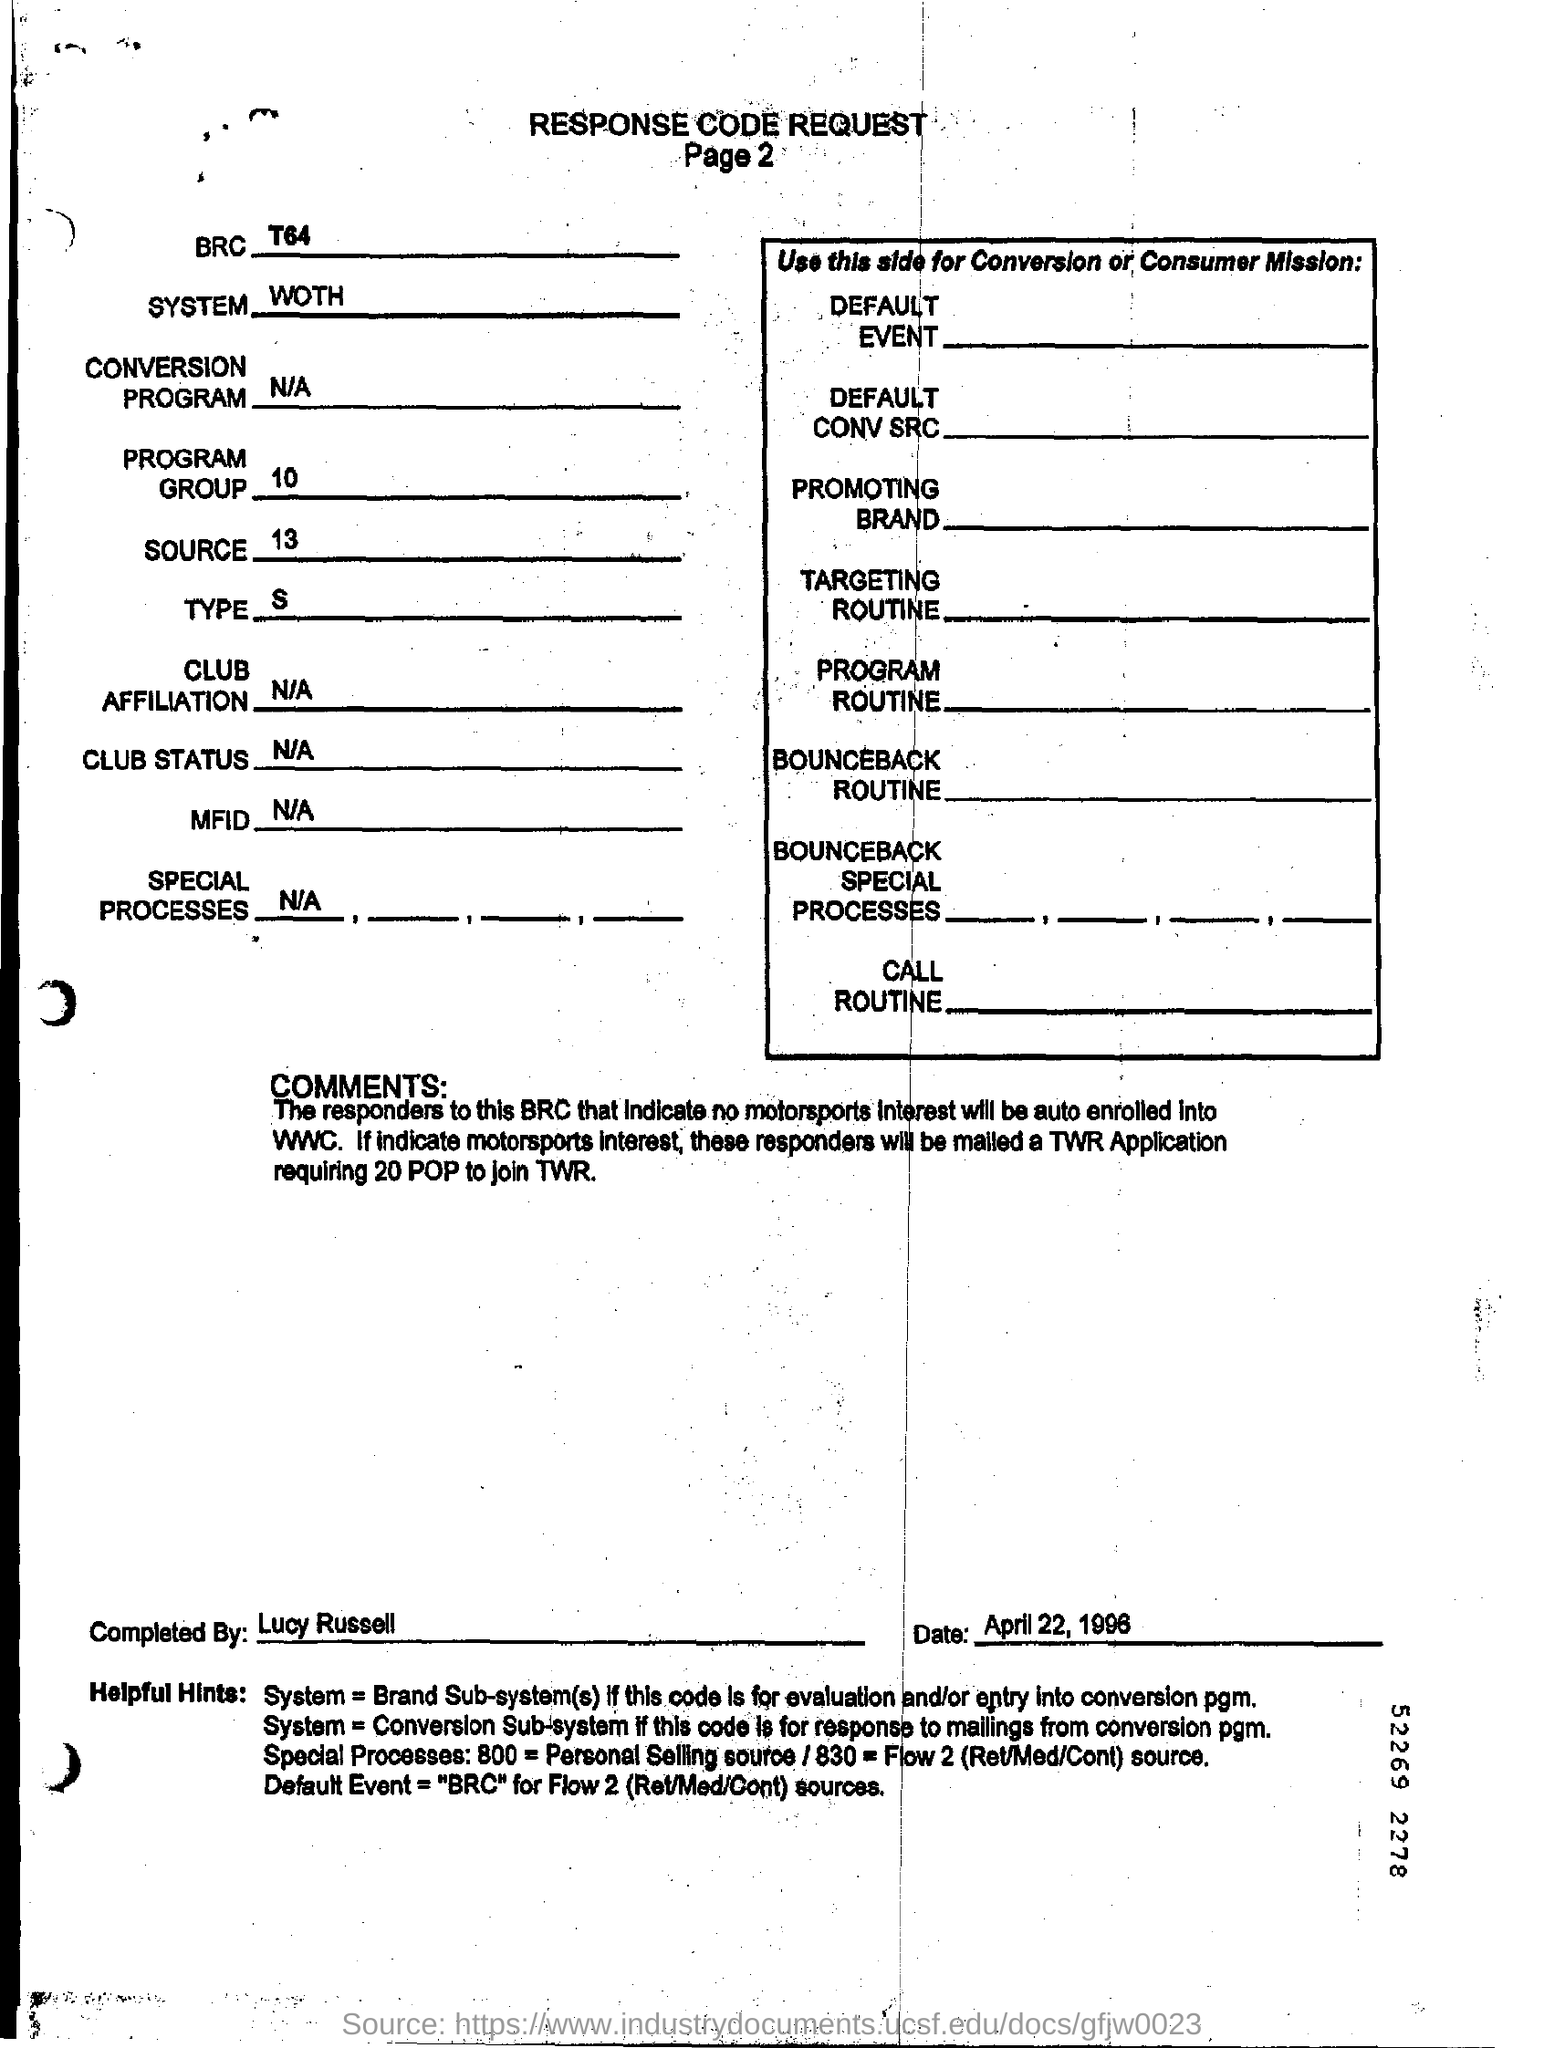Specify some key components in this picture. It is declared that Lucy Russell completed this document. What is the number of Program Group? It is 10.. The date of the document is April 22, 1996. This document has two pages. What is "type" mentioned in the document?" is a question asking for information about the meaning or definition of the term "type" as it is used in a particular document. 